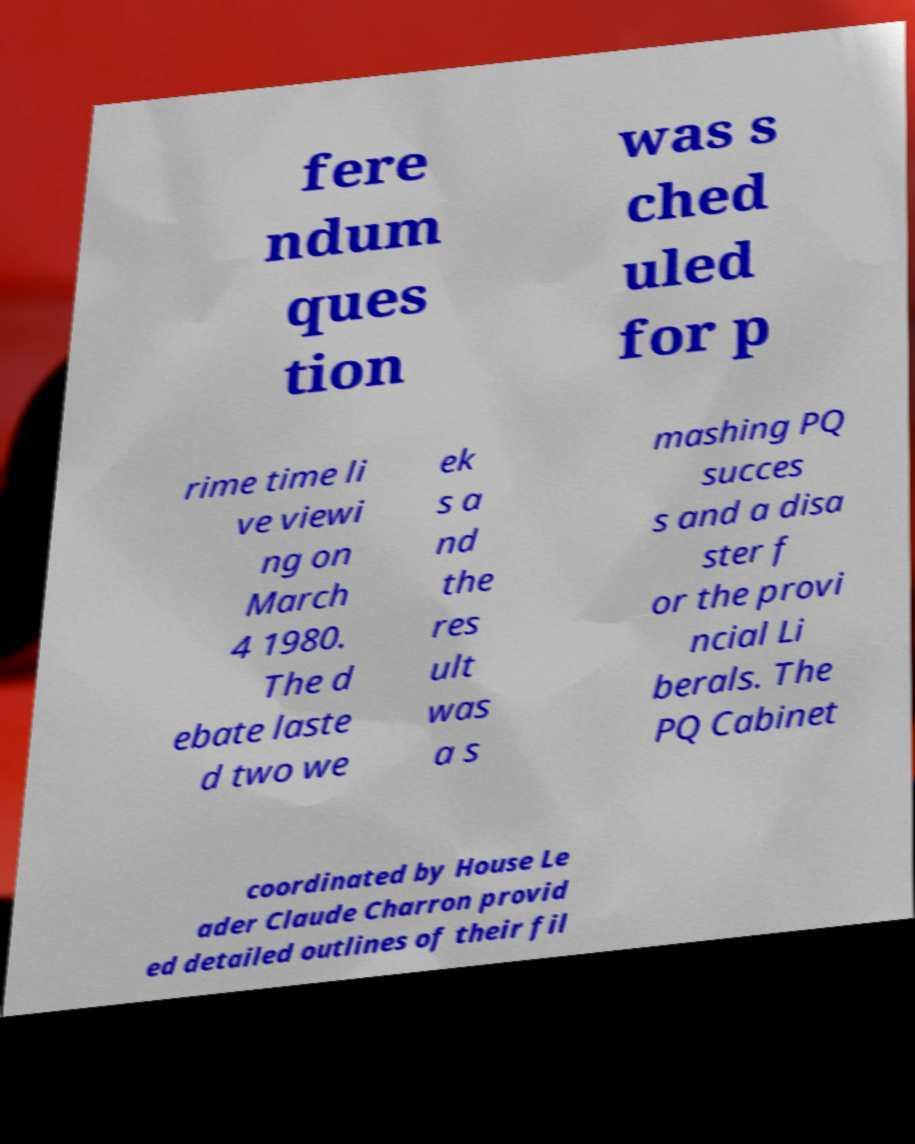Could you extract and type out the text from this image? fere ndum ques tion was s ched uled for p rime time li ve viewi ng on March 4 1980. The d ebate laste d two we ek s a nd the res ult was a s mashing PQ succes s and a disa ster f or the provi ncial Li berals. The PQ Cabinet coordinated by House Le ader Claude Charron provid ed detailed outlines of their fil 